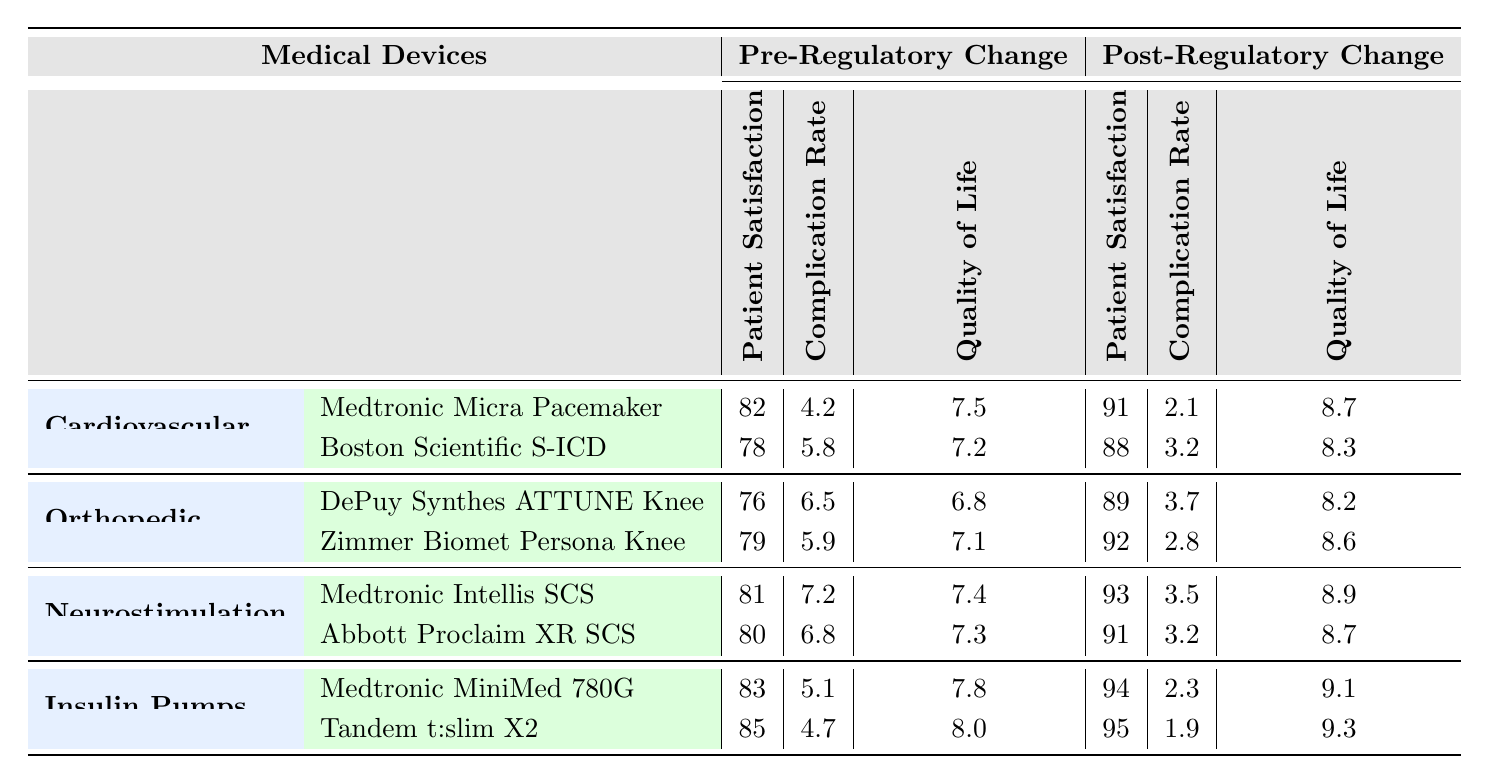What is the patient satisfaction rate for the Medtronic Micra Pacemaker post-regulatory change? The table shows that the patient satisfaction rate for the Medtronic Micra Pacemaker post-regulatory change is listed as 91.
Answer: 91 What was the complication rate for the Boston Scientific S-ICD pre-regulatory change? According to the table, the complication rate for the Boston Scientific S-ICD pre-regulatory change is 5.8.
Answer: 5.8 Which device had the highest improvement in quality of life post-regulatory change? By comparing the quality of life improvement post-regulatory change for each device, Medtronic MiniMed 780G (9.1) and Tandem t:slim X2 (9.3) had the highest improvement, with Tandem t:slim X2 being slightly higher.
Answer: Tandem t:slim X2 (9.3) Did the patient satisfaction for all devices improve post-regulatory changes? Examination of the pre and post-regulatory change patient satisfaction rates confirms that all listed devices experienced an increase in patient satisfaction post-regulatory changes.
Answer: Yes What is the average patient satisfaction rate for all devices pre-regulatory change? To find the average, add the patient satisfaction rates pre-regulatory change: (82 + 78 + 76 + 79 + 81 + 80 + 83 + 85) = 624. There are 8 devices, so the average is 624/8 = 78.
Answer: 78 Which category of devices showed the largest difference in complication rates pre and post-regulatory change? By assessing the difference in complication rates for each device category, the largest difference is seen in Cardiovascular Devices: Medtronic Micra Pacemaker (4.2 to 2.1 = 2.1 improvement) and Boston Scientific S-ICD (5.8 to 3.2 = 2.6 improvement). Overall, the highest difference is in Neurostimulation devices, specifically between the devices, with a close comparison of complication rates.
Answer: Neurostimulation devices What was the quality of life improvement for the Zimmer Biomet Persona Knee post-regulatory change? The table shows that the quality of life improvement for the Zimmer Biomet Persona Knee post-regulatory change is 8.6.
Answer: 8.6 Is the complication rate for the Tandem t:slim X2 lower than that of the DePuy Synthes ATTUNE Knee System post-regulatory change? Comparing the post-regulatory change complication rates, Tandem t:slim X2 shows a complication rate of 1.9, which is lower than that of DePuy Synthes ATTUNE Knee System at 3.7.
Answer: Yes What is the total quality of life improvement for all Neurostimulation devices pre-regulatory change? The quality of life improvement for Neurostimulation devices pre-regulatory change is calculated as: Medtronic Intellis (7.4) + Abbott Proclaim (7.3) = 14.7 total improvement.
Answer: 14.7 Which medical device category had the highest patient satisfaction rate post-regulatory change? To find the highest patient satisfaction rate post-regulatory change, we check the maximum rates: Cardiovascular (91, 88), Orthopedic (89, 92), Neurostimulation (93, 91), Insulin Pumps (94, 95). The highest is for Insulin Pumps with 95.
Answer: Insulin Pumps 